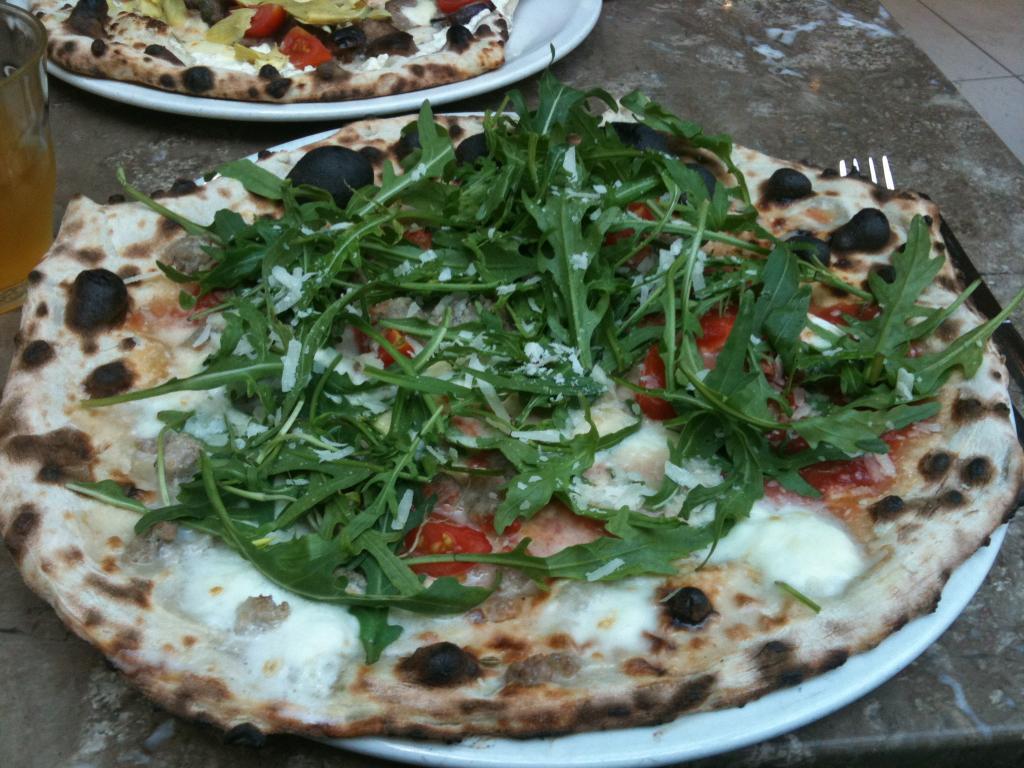In one or two sentences, can you explain what this image depicts? In this picture, it seems like a pizza on a plate in the foreground area of the image, there is a glass and another plate at the top side. There is a fork on the right side. 